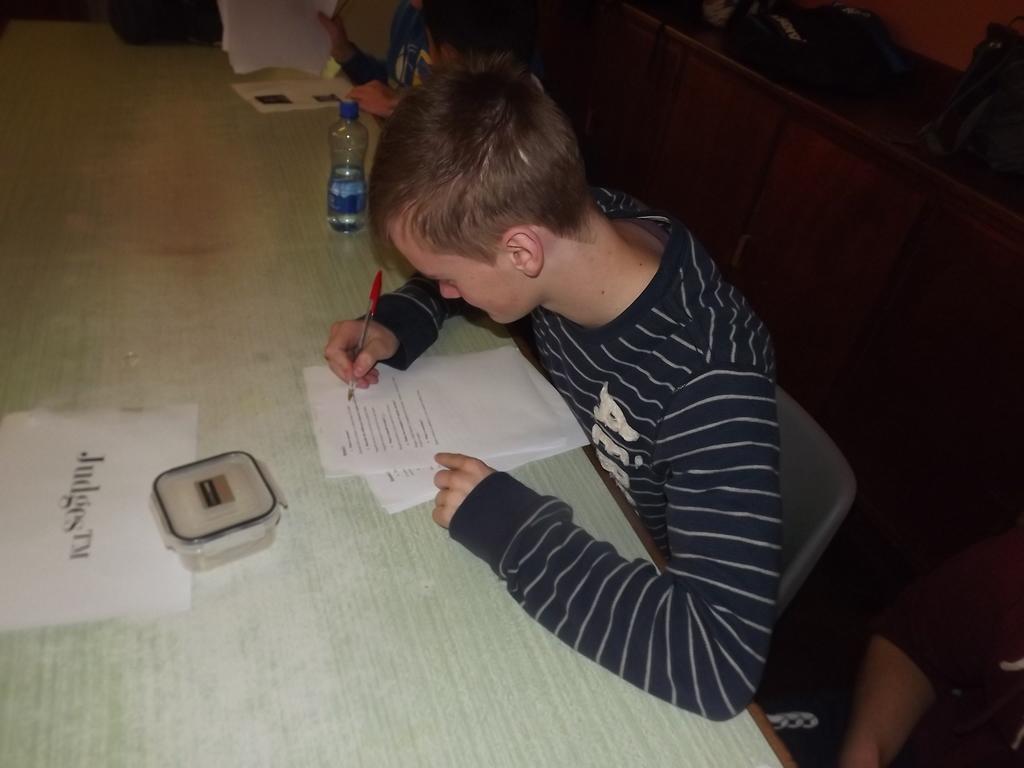How would you summarize this image in a sentence or two? Here in this picture we can a person sitting on a chair with table in front of him and he is trying to write something on paper present on the table with the help of pen in his hand and we can also see a box present and beside him we can see a bottle present and we can see other pages also present over there. 